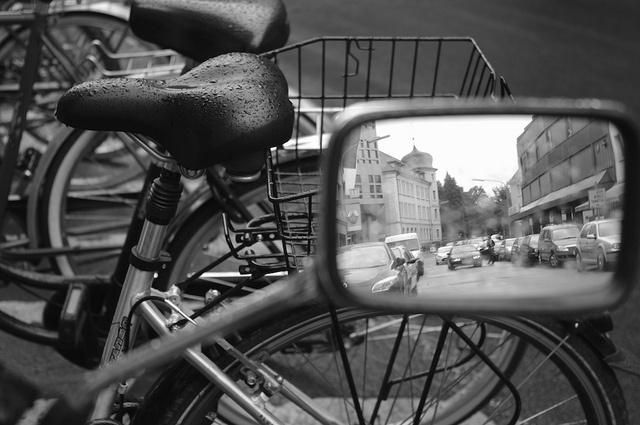Describe the objects in this image and their specific colors. I can see bicycle in black, gray, and lightgray tones, bicycle in black, gray, darkgray, and lightgray tones, bicycle in black, gray, darkgray, and lightgray tones, bicycle in black, gray, and lightgray tones, and bicycle in black, gray, and silver tones in this image. 